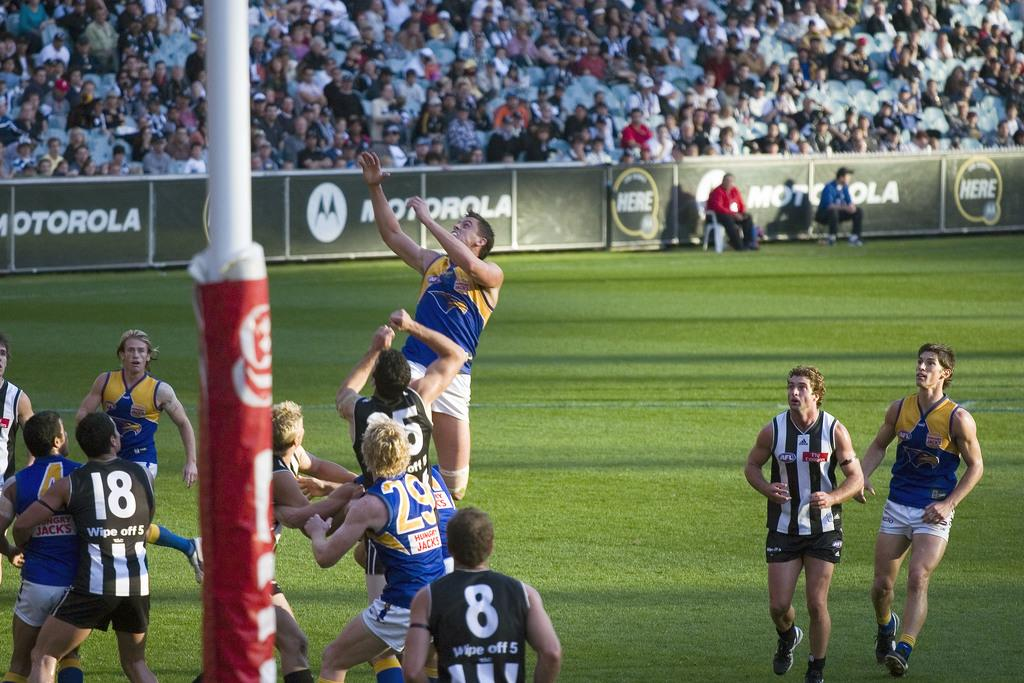<image>
Write a terse but informative summary of the picture. a sports game with players on the field near signs for Motorola 